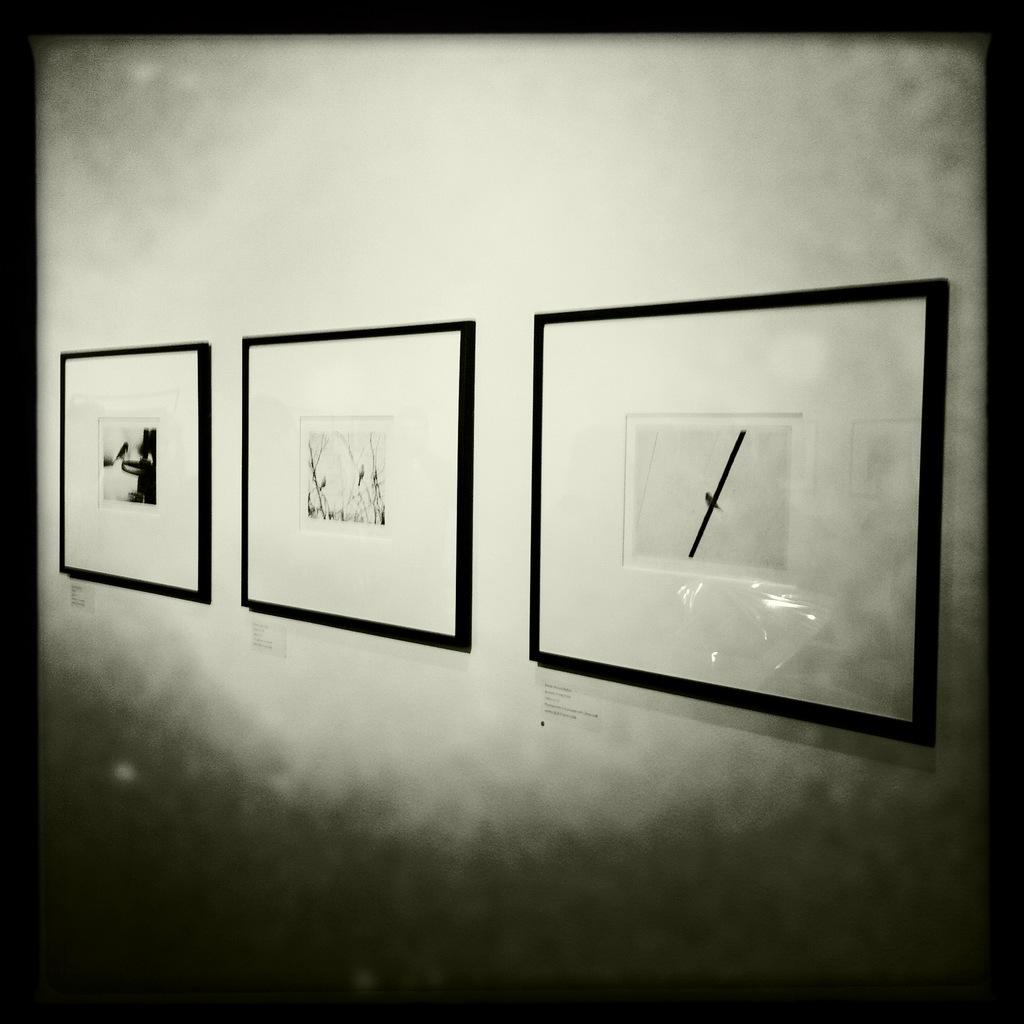What is the color scheme of the image? The image is black and white. Where was the image taken? The image was taken indoors. What can be seen on the wall in the image? There is a wall with three picture frames on it. What type of curtain is hanging in front of the window in the image? There is no window or curtain present in the image. What type of vessel is being used to serve the soup in the image? There is no soup or vessel present in the image. 